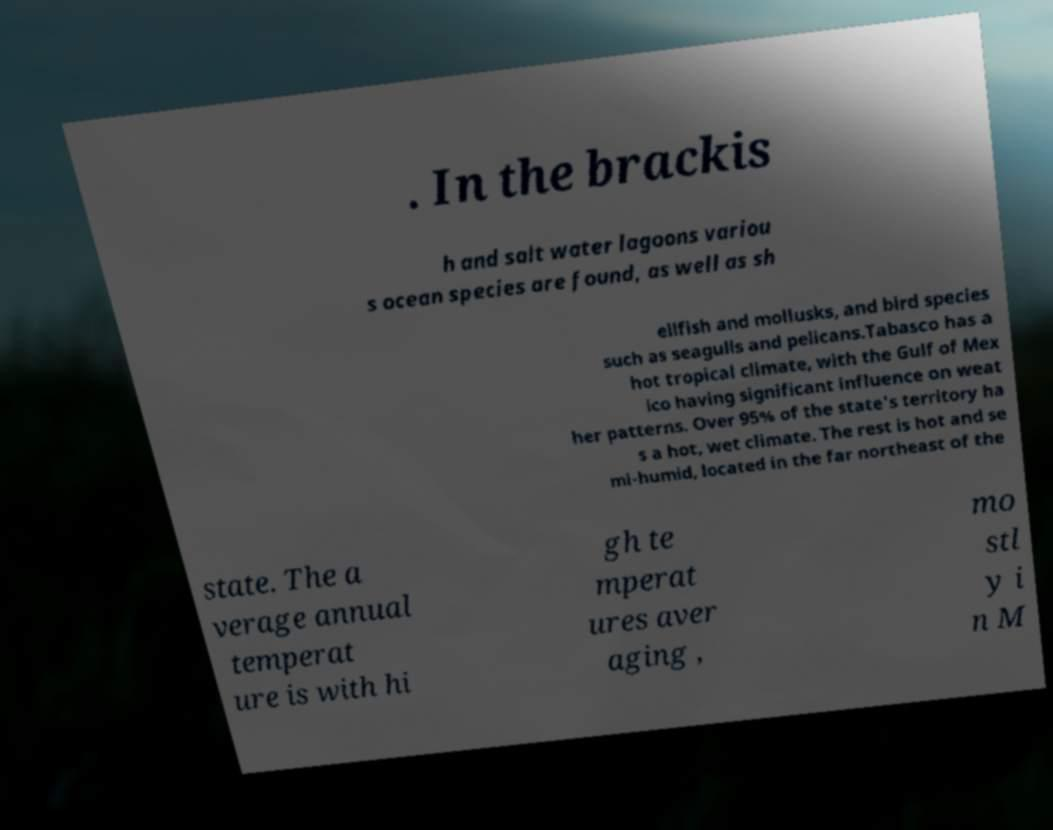There's text embedded in this image that I need extracted. Can you transcribe it verbatim? . In the brackis h and salt water lagoons variou s ocean species are found, as well as sh ellfish and mollusks, and bird species such as seagulls and pelicans.Tabasco has a hot tropical climate, with the Gulf of Mex ico having significant influence on weat her patterns. Over 95% of the state's territory ha s a hot, wet climate. The rest is hot and se mi-humid, located in the far northeast of the state. The a verage annual temperat ure is with hi gh te mperat ures aver aging , mo stl y i n M 